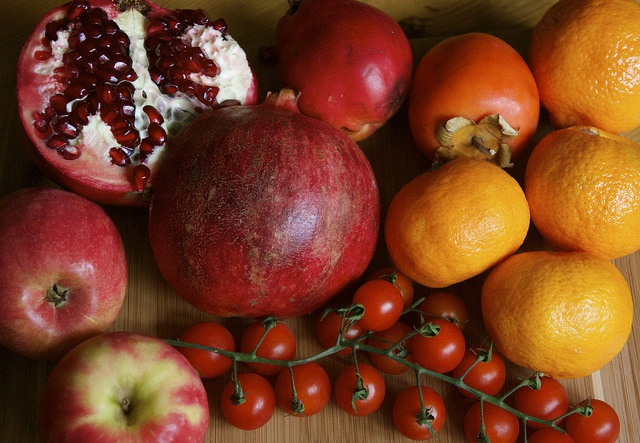Describe the objects in this image and their specific colors. I can see apple in black, maroon, and brown tones, orange in black, orange, brown, and maroon tones, apple in black, brown, and maroon tones, orange in black, orange, red, and maroon tones, and orange in black, orange, brown, and maroon tones in this image. 